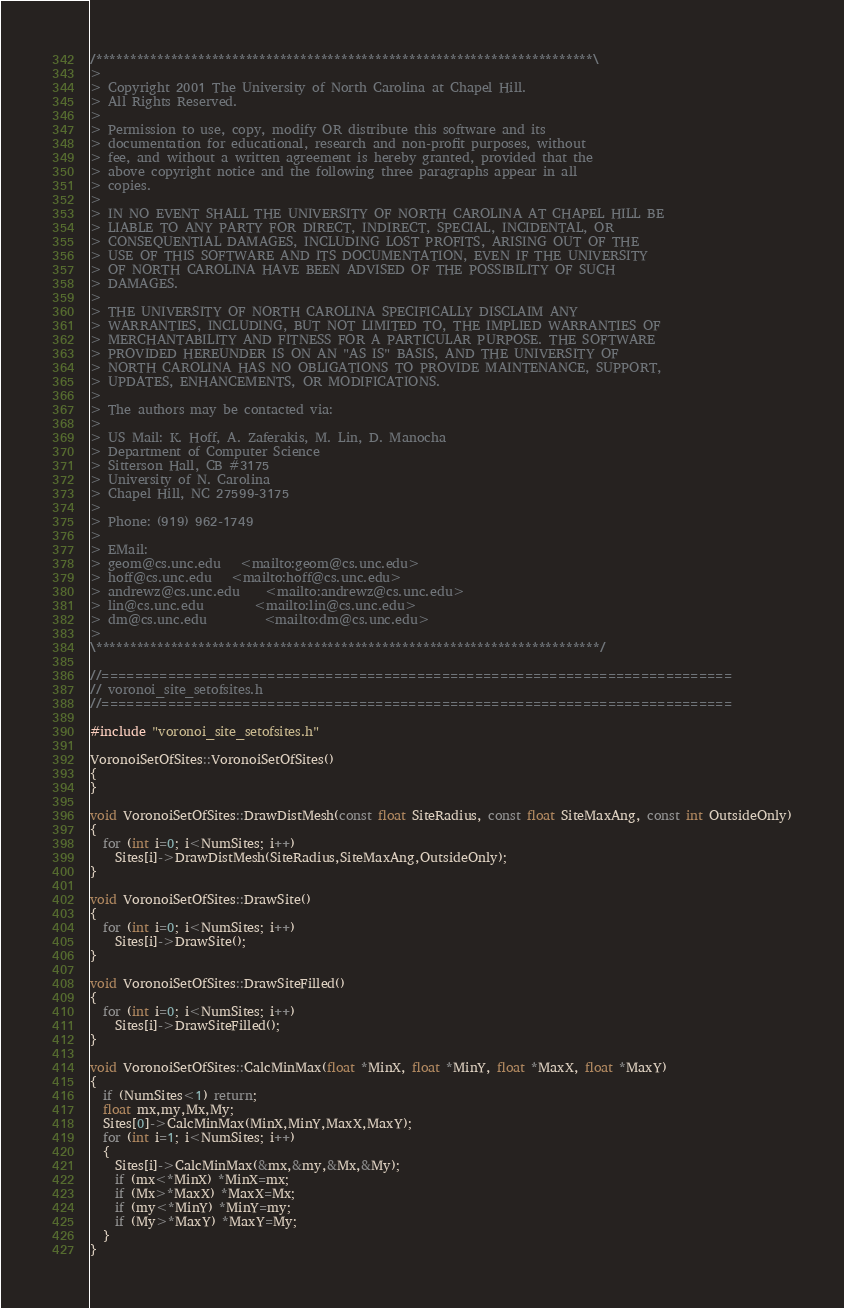<code> <loc_0><loc_0><loc_500><loc_500><_C++_>/*************************************************************************\
>
> Copyright 2001 The University of North Carolina at Chapel Hill.
> All Rights Reserved.
>
> Permission to use, copy, modify OR distribute this software and its
> documentation for educational, research and non-profit purposes, without
> fee, and without a written agreement is hereby granted, provided that the
> above copyright notice and the following three paragraphs appear in all
> copies.
>
> IN NO EVENT SHALL THE UNIVERSITY OF NORTH CAROLINA AT CHAPEL HILL BE
> LIABLE TO ANY PARTY FOR DIRECT, INDIRECT, SPECIAL, INCIDENTAL, OR
> CONSEQUENTIAL DAMAGES, INCLUDING LOST PROFITS, ARISING OUT OF THE
> USE OF THIS SOFTWARE AND ITS DOCUMENTATION, EVEN IF THE UNIVERSITY
> OF NORTH CAROLINA HAVE BEEN ADVISED OF THE POSSIBILITY OF SUCH
> DAMAGES.
>
> THE UNIVERSITY OF NORTH CAROLINA SPECIFICALLY DISCLAIM ANY
> WARRANTIES, INCLUDING, BUT NOT LIMITED TO, THE IMPLIED WARRANTIES OF
> MERCHANTABILITY AND FITNESS FOR A PARTICULAR PURPOSE. THE SOFTWARE
> PROVIDED HEREUNDER IS ON AN "AS IS" BASIS, AND THE UNIVERSITY OF
> NORTH CAROLINA HAS NO OBLIGATIONS TO PROVIDE MAINTENANCE, SUPPORT,
> UPDATES, ENHANCEMENTS, OR MODIFICATIONS.
>
> The authors may be contacted via:
>
> US Mail: K. Hoff, A. Zaferakis, M. Lin, D. Manocha
> Department of Computer Science
> Sitterson Hall, CB #3175
> University of N. Carolina
> Chapel Hill, NC 27599-3175
>
> Phone: (919) 962-1749
>
> EMail: 
> geom@cs.unc.edu 	<mailto:geom@cs.unc.edu>
> hoff@cs.unc.edu 	<mailto:hoff@cs.unc.edu>
> andrewz@cs.unc.edu 	<mailto:andrewz@cs.unc.edu>
> lin@cs.unc.edu 		<mailto:lin@cs.unc.edu>
> dm@cs.unc.edu 		<mailto:dm@cs.unc.edu>
>
\**************************************************************************/

//============================================================================
// voronoi_site_setofsites.h
//============================================================================

#include "voronoi_site_setofsites.h"

VoronoiSetOfSites::VoronoiSetOfSites()
{
}

void VoronoiSetOfSites::DrawDistMesh(const float SiteRadius, const float SiteMaxAng, const int OutsideOnly)
{
  for (int i=0; i<NumSites; i++)
    Sites[i]->DrawDistMesh(SiteRadius,SiteMaxAng,OutsideOnly);
}

void VoronoiSetOfSites::DrawSite()
{
  for (int i=0; i<NumSites; i++)
    Sites[i]->DrawSite();
}

void VoronoiSetOfSites::DrawSiteFilled()
{
  for (int i=0; i<NumSites; i++)
    Sites[i]->DrawSiteFilled();
}

void VoronoiSetOfSites::CalcMinMax(float *MinX, float *MinY, float *MaxX, float *MaxY)
{
  if (NumSites<1) return;
  float mx,my,Mx,My;
  Sites[0]->CalcMinMax(MinX,MinY,MaxX,MaxY);
  for (int i=1; i<NumSites; i++)
  {
    Sites[i]->CalcMinMax(&mx,&my,&Mx,&My);
    if (mx<*MinX) *MinX=mx;
    if (Mx>*MaxX) *MaxX=Mx;
    if (my<*MinY) *MinY=my;
    if (My>*MaxY) *MaxY=My;
  }
}
</code> 